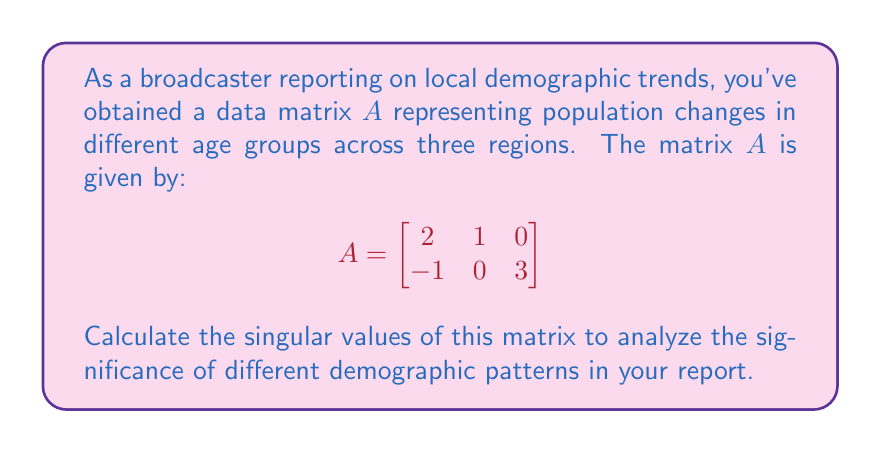Show me your answer to this math problem. To find the singular values of matrix $A$, we follow these steps:

1) First, calculate $A^TA$:
   $$A^TA = \begin{bmatrix}
   2 & -1 \\
   1 & 0 \\
   0 & 3
   \end{bmatrix} \begin{bmatrix}
   2 & 1 & 0 \\
   -1 & 0 & 3
   \end{bmatrix} = \begin{bmatrix}
   5 & 2 & -3 \\
   2 & 1 & 0 \\
   -3 & 0 & 9
   \end{bmatrix}$$

2) Find the eigenvalues of $A^TA$ by solving the characteristic equation:
   $$\det(A^TA - \lambda I) = 0$$
   
   $$\begin{vmatrix}
   5-\lambda & 2 & -3 \\
   2 & 1-\lambda & 0 \\
   -3 & 0 & 9-\lambda
   \end{vmatrix} = 0$$

3) Expanding the determinant:
   $(5-\lambda)[(1-\lambda)(9-\lambda)] + 2[-3(1-\lambda)] + (-3)[2(9-\lambda)] = 0$
   
   $(5-\lambda)(9-9\lambda+\lambda^2) - 6(1-\lambda) - 54 + 6\lambda = 0$
   
   $45-45\lambda+5\lambda^2-9\lambda+9\lambda^2-\lambda^3 - 6 + 6\lambda - 54 + 6\lambda = 0$
   
   $-\lambda^3 + 14\lambda^2 - 42\lambda - 15 = 0$

4) Solving this cubic equation (you can use a calculator or computer algebra system), we get:
   $\lambda_1 = 10$, $\lambda_2 = 5$, $\lambda_3 = -1$

5) The singular values are the square roots of the positive eigenvalues:
   $\sigma_1 = \sqrt{10}$, $\sigma_2 = \sqrt{5}$

These singular values indicate the strength of the two most significant demographic patterns in your data.
Answer: $\sigma_1 = \sqrt{10}$, $\sigma_2 = \sqrt{5}$ 